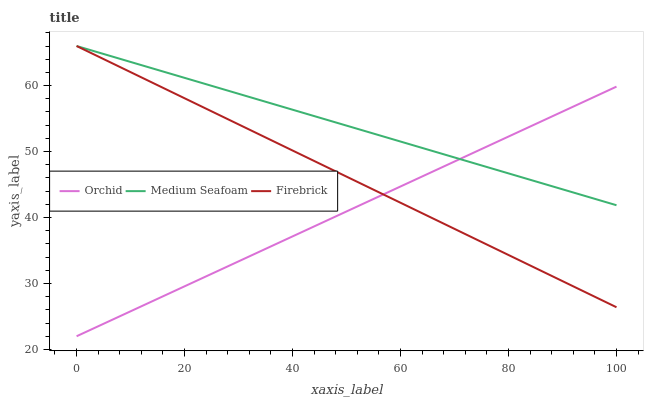Does Orchid have the minimum area under the curve?
Answer yes or no. Yes. Does Medium Seafoam have the maximum area under the curve?
Answer yes or no. Yes. Does Medium Seafoam have the minimum area under the curve?
Answer yes or no. No. Does Orchid have the maximum area under the curve?
Answer yes or no. No. Is Orchid the smoothest?
Answer yes or no. Yes. Is Medium Seafoam the roughest?
Answer yes or no. Yes. Is Medium Seafoam the smoothest?
Answer yes or no. No. Is Orchid the roughest?
Answer yes or no. No. Does Medium Seafoam have the lowest value?
Answer yes or no. No. Does Medium Seafoam have the highest value?
Answer yes or no. Yes. Does Orchid have the highest value?
Answer yes or no. No. Does Orchid intersect Medium Seafoam?
Answer yes or no. Yes. Is Orchid less than Medium Seafoam?
Answer yes or no. No. Is Orchid greater than Medium Seafoam?
Answer yes or no. No. 